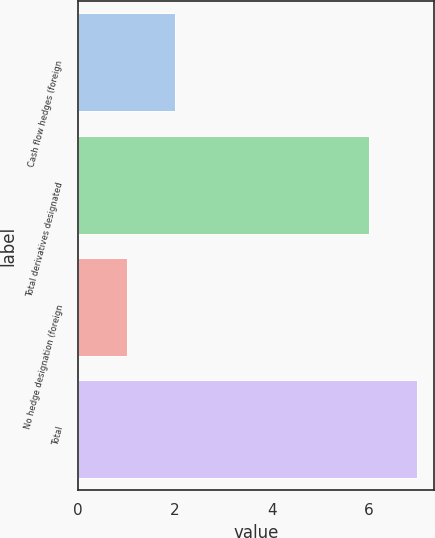<chart> <loc_0><loc_0><loc_500><loc_500><bar_chart><fcel>Cash flow hedges (foreign<fcel>Total derivatives designated<fcel>No hedge designation (foreign<fcel>Total<nl><fcel>2<fcel>6<fcel>1<fcel>7<nl></chart> 